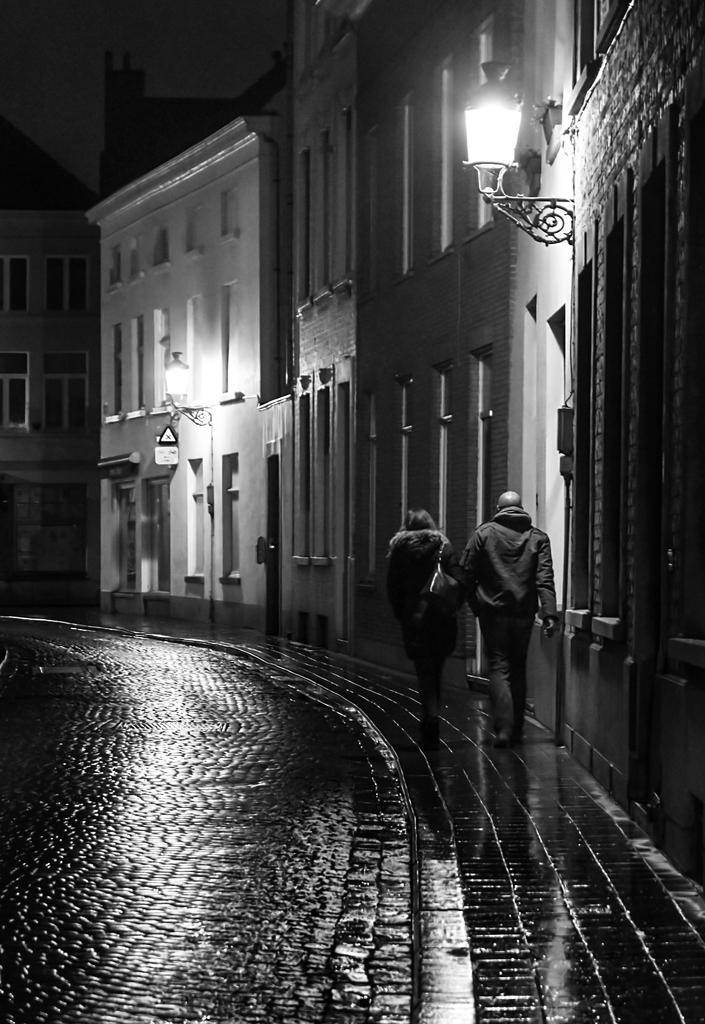Describe this image in one or two sentences. This image consists of two persons walking on the pavement. On the left, there is a road. On the right, there are buildings along with the lights. At the top, there is sky. 